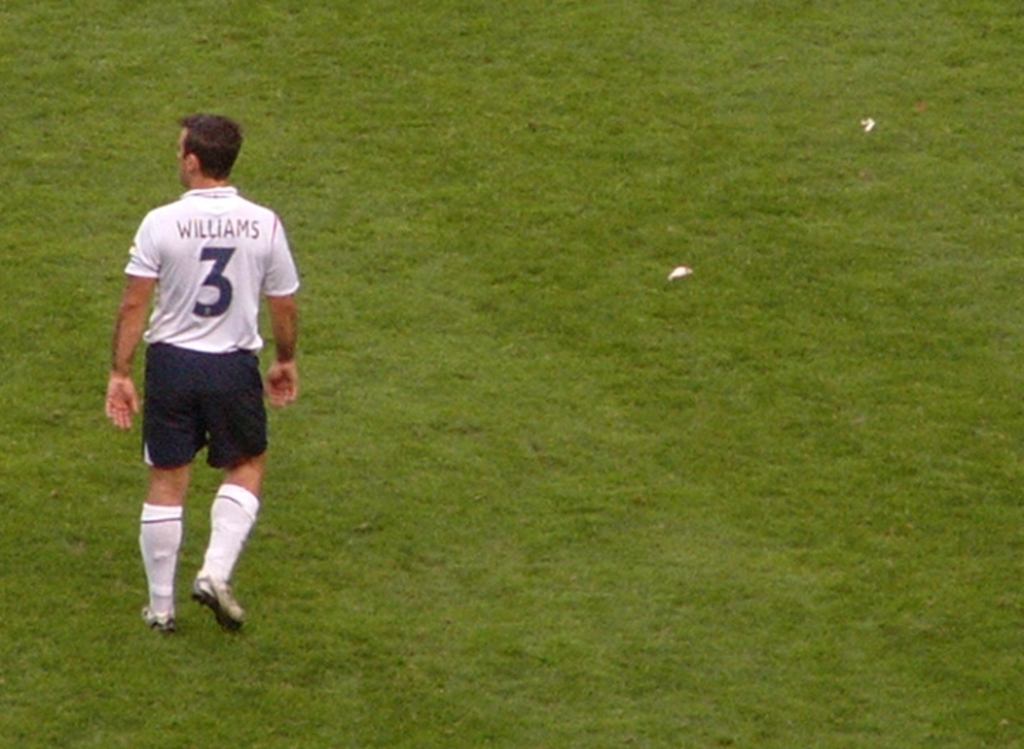What kind of event might this image depict, and what are the visible signs that support your assumption? This image likely depicts a soccer match. The visible clues are the soccer player dressed in a typical kit, including shorts, a jersey with a number, and cleats, as well as the obvious grass field commonly used in soccer games. 